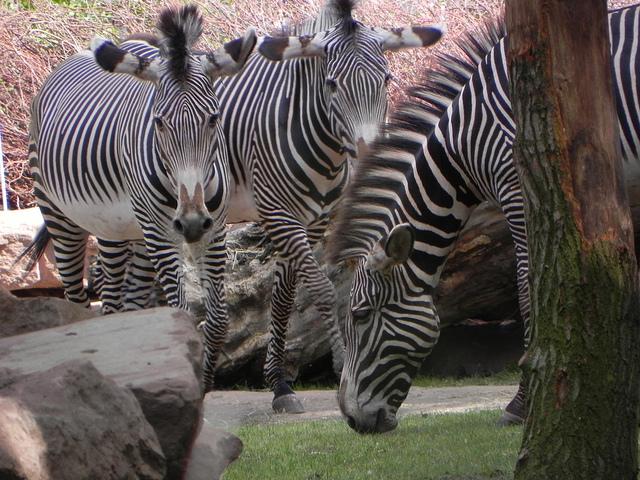How many zebras are there?
Short answer required. 3. What animal is there a lot of?
Keep it brief. Zebra. How many stripes are there?
Concise answer only. Lot. Is the zebra on the far right drinking water?
Be succinct. No. How many zebra are there?
Give a very brief answer. 3. How many zebras are looking at the camera?
Answer briefly. 2. How many animals are there?
Keep it brief. 3. How many zebras?
Concise answer only. 3. How many zebras are pictured?
Give a very brief answer. 3. Is one of the zebras grazing?
Keep it brief. Yes. 